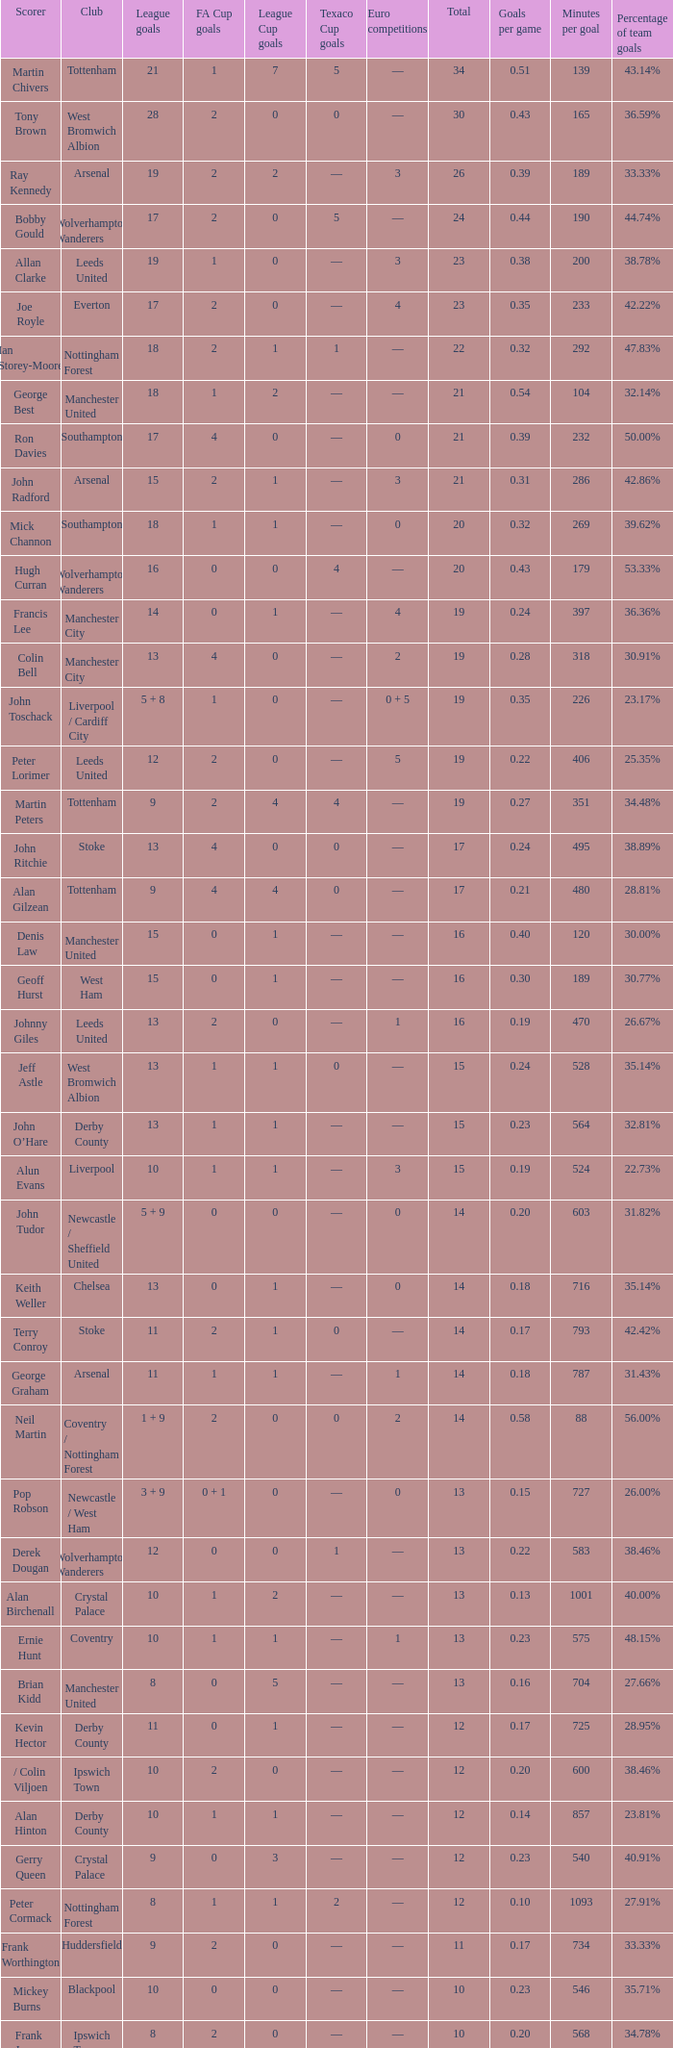What is FA Cup Goals, when Euro Competitions is 1, and when League Goals is 11? 1.0. 